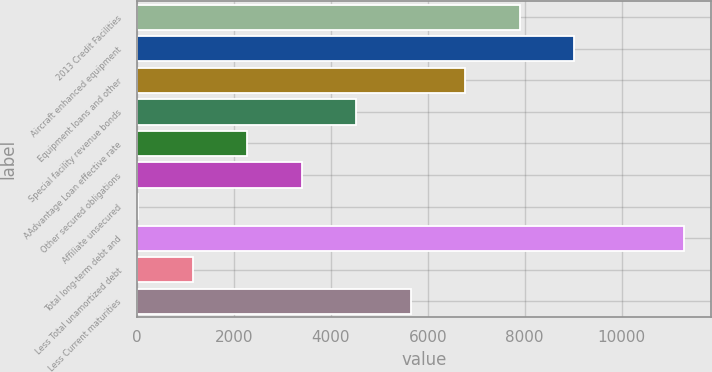Convert chart. <chart><loc_0><loc_0><loc_500><loc_500><bar_chart><fcel>2013 Credit Facilities<fcel>Aircraft enhanced equipment<fcel>Equipment loans and other<fcel>Special facility revenue bonds<fcel>AAdvantage Loan effective rate<fcel>Other secured obligations<fcel>Affiliate unsecured<fcel>Total long-term debt and<fcel>Less Total unamortized debt<fcel>Less Current maturities<nl><fcel>7901.3<fcel>9026.2<fcel>6776.4<fcel>4526.6<fcel>2276.8<fcel>3401.7<fcel>27<fcel>11276<fcel>1151.9<fcel>5651.5<nl></chart> 